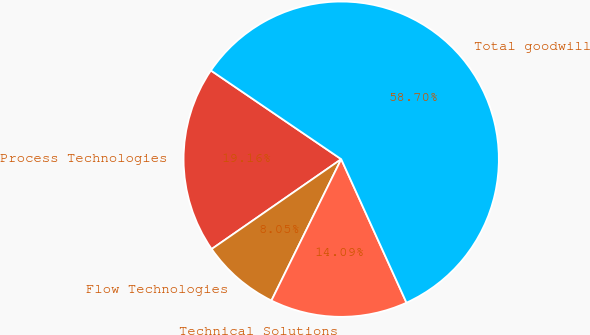Convert chart to OTSL. <chart><loc_0><loc_0><loc_500><loc_500><pie_chart><fcel>Process Technologies<fcel>Flow Technologies<fcel>Technical Solutions<fcel>Total goodwill<nl><fcel>19.16%<fcel>8.05%<fcel>14.09%<fcel>58.69%<nl></chart> 